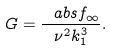Convert formula to latex. <formula><loc_0><loc_0><loc_500><loc_500>G = \frac { \ a b s { f } _ { \infty } } { \nu ^ { 2 } k _ { 1 } ^ { 3 } } .</formula> 